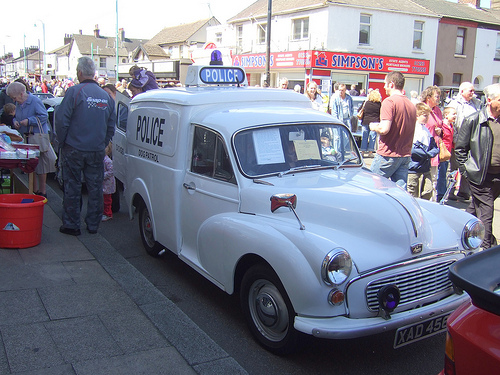<image>
Is the car next to the man? Yes. The car is positioned adjacent to the man, located nearby in the same general area. Is the car to the right of the man? Yes. From this viewpoint, the car is positioned to the right side relative to the man. 